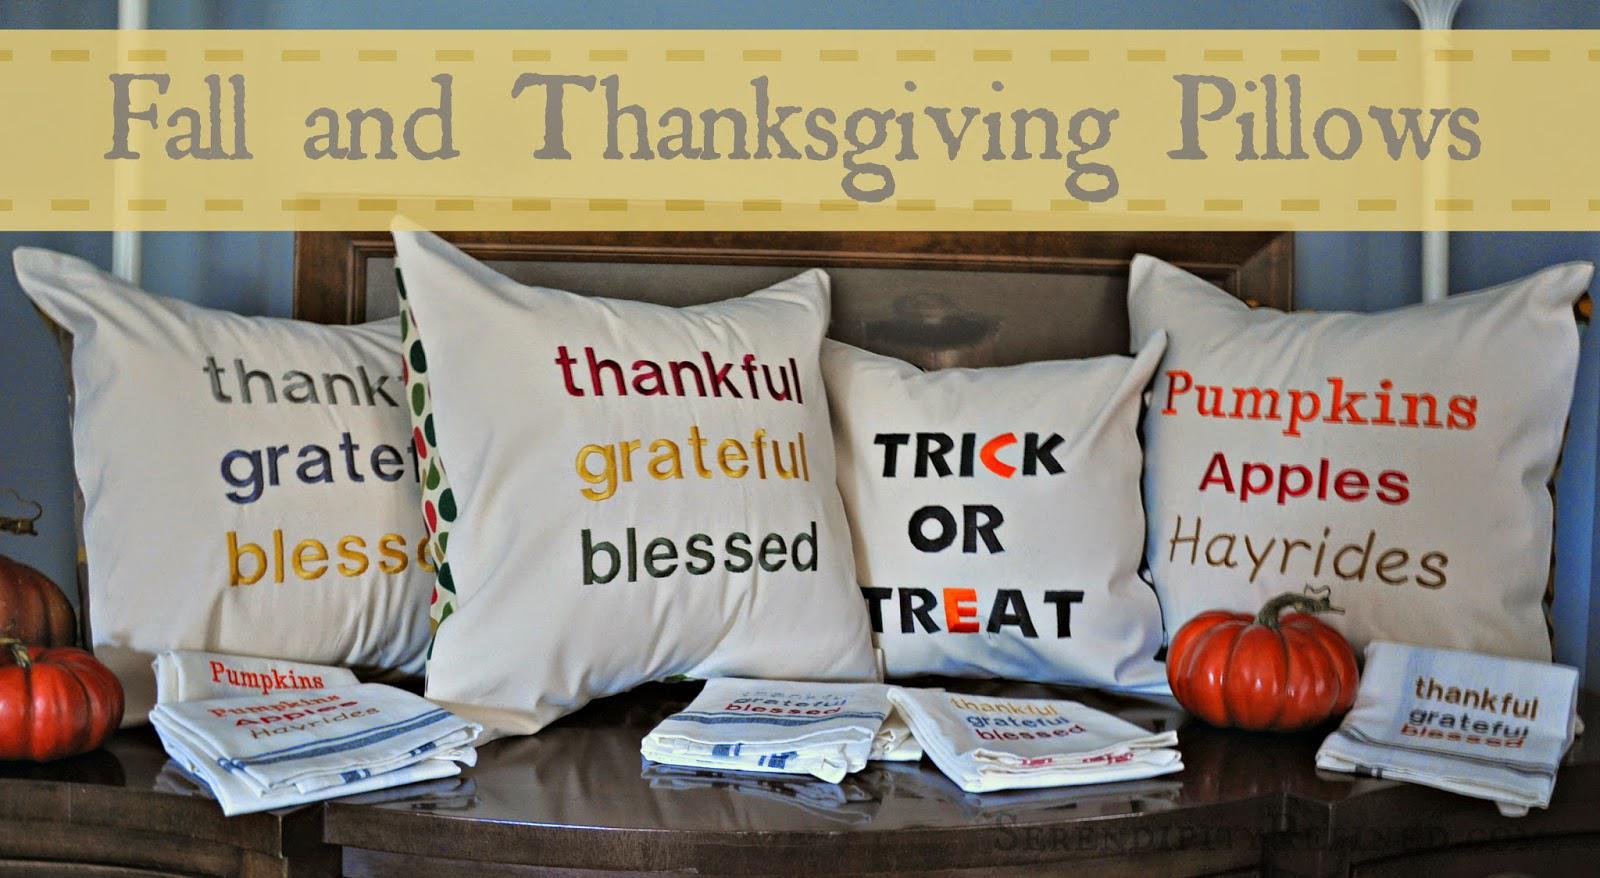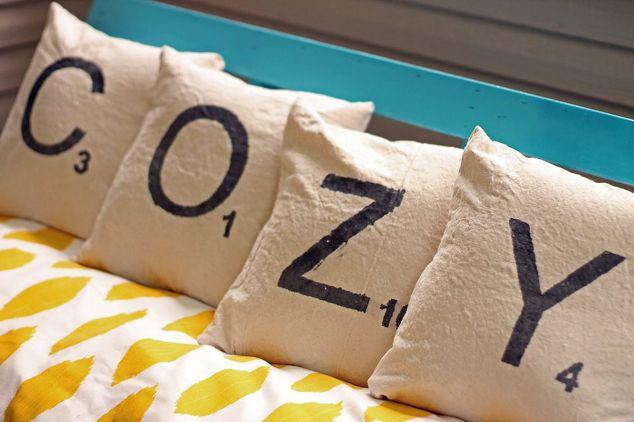The first image is the image on the left, the second image is the image on the right. Evaluate the accuracy of this statement regarding the images: "One image has a pillow with vertical strips going down the center.". Is it true? Answer yes or no. No. The first image is the image on the left, the second image is the image on the right. Considering the images on both sides, is "None of the pillows contain the number '25'." valid? Answer yes or no. Yes. 